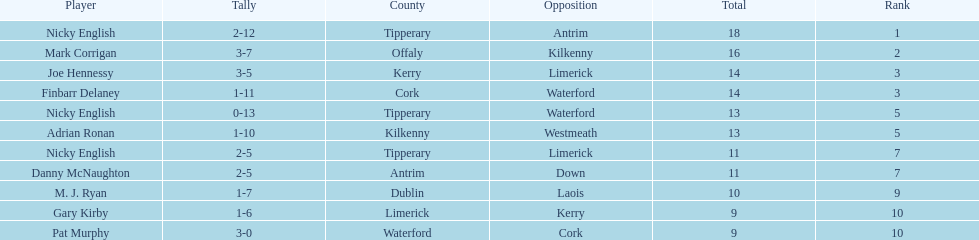I'm looking to parse the entire table for insights. Could you assist me with that? {'header': ['Player', 'Tally', 'County', 'Opposition', 'Total', 'Rank'], 'rows': [['Nicky English', '2-12', 'Tipperary', 'Antrim', '18', '1'], ['Mark Corrigan', '3-7', 'Offaly', 'Kilkenny', '16', '2'], ['Joe Hennessy', '3-5', 'Kerry', 'Limerick', '14', '3'], ['Finbarr Delaney', '1-11', 'Cork', 'Waterford', '14', '3'], ['Nicky English', '0-13', 'Tipperary', 'Waterford', '13', '5'], ['Adrian Ronan', '1-10', 'Kilkenny', 'Westmeath', '13', '5'], ['Nicky English', '2-5', 'Tipperary', 'Limerick', '11', '7'], ['Danny McNaughton', '2-5', 'Antrim', 'Down', '11', '7'], ['M. J. Ryan', '1-7', 'Dublin', 'Laois', '10', '9'], ['Gary Kirby', '1-6', 'Limerick', 'Kerry', '9', '10'], ['Pat Murphy', '3-0', 'Waterford', 'Cork', '9', '10']]} How many people are on the list? 9. 